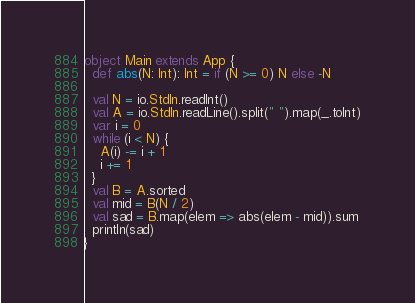<code> <loc_0><loc_0><loc_500><loc_500><_Scala_>object Main extends App {
  def abs(N: Int): Int = if (N >= 0) N else -N

  val N = io.StdIn.readInt()
  val A = io.StdIn.readLine().split(" ").map(_.toInt)
  var i = 0
  while (i < N) {
    A(i) -= i + 1
    i += 1
  }
  val B = A.sorted
  val mid = B(N / 2)
  val sad = B.map(elem => abs(elem - mid)).sum
  println(sad)
}
</code> 